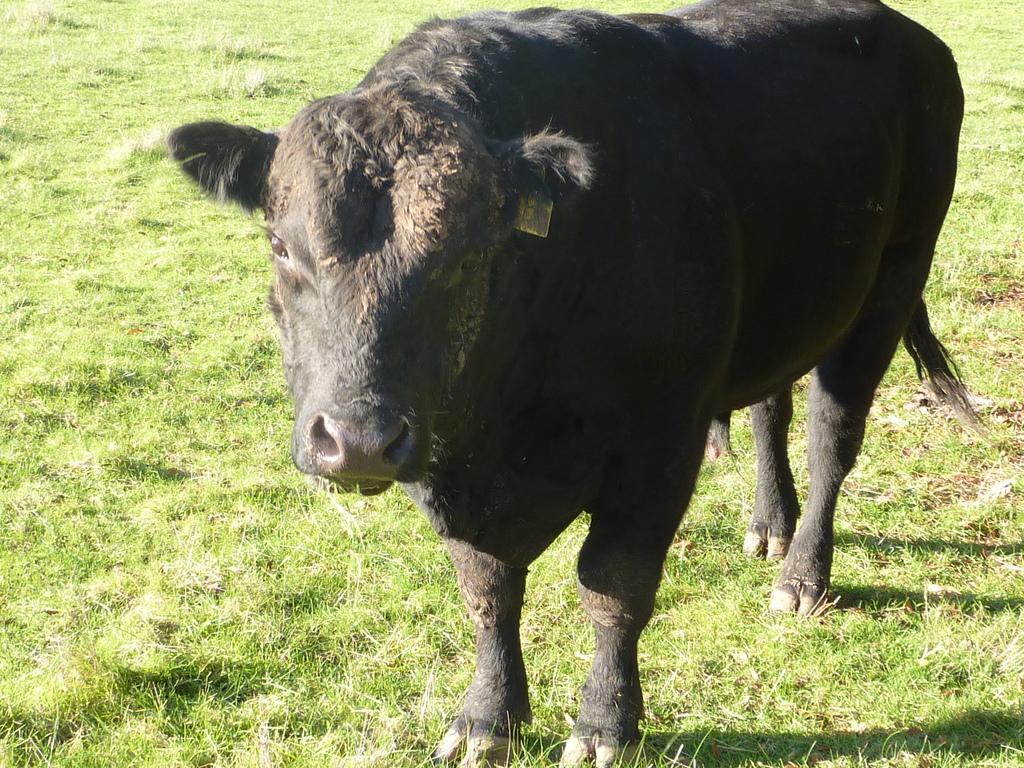What animal is the main subject of the picture? There is a buffalo in the picture. Where is the buffalo positioned in the image? The buffalo is standing in the front. What type of vegetation is visible at the bottom of the picture? There is grass at the bottom of the picture. What type of pie is being served at the buffalo's nation's representative meeting? There is no information about a pie, a nation, or a representative meeting in the image, so it cannot be determined from the picture. 